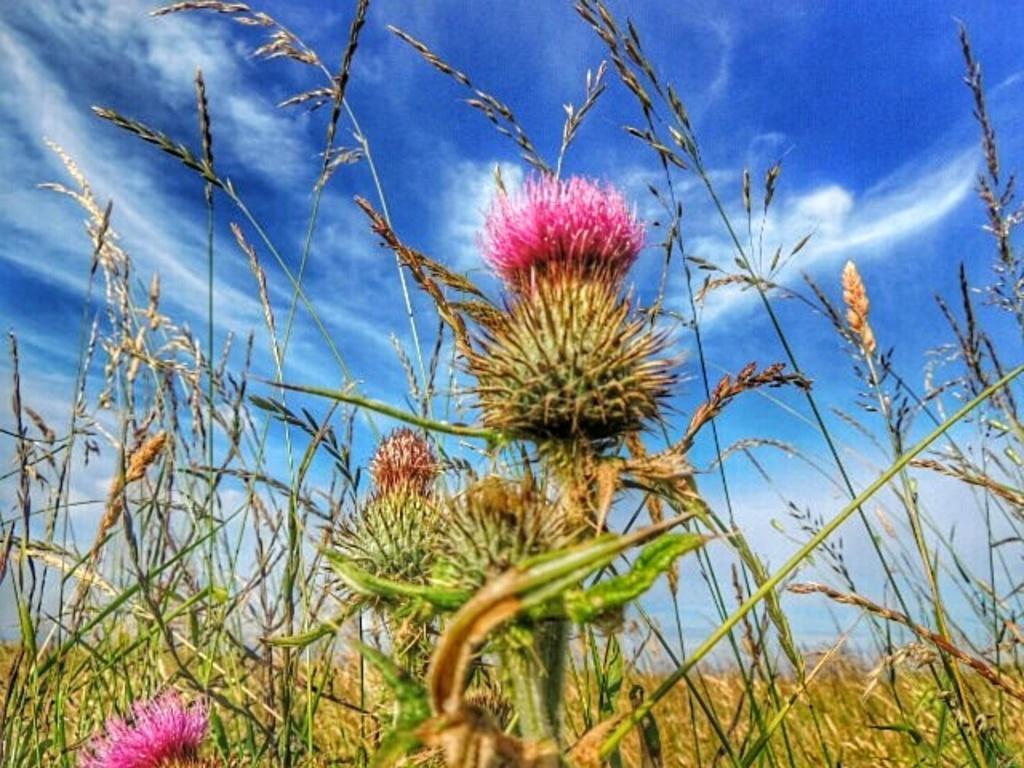Can you describe this image briefly? In this picture we can see plants with flowers and in the background we can see sky with clouds. 